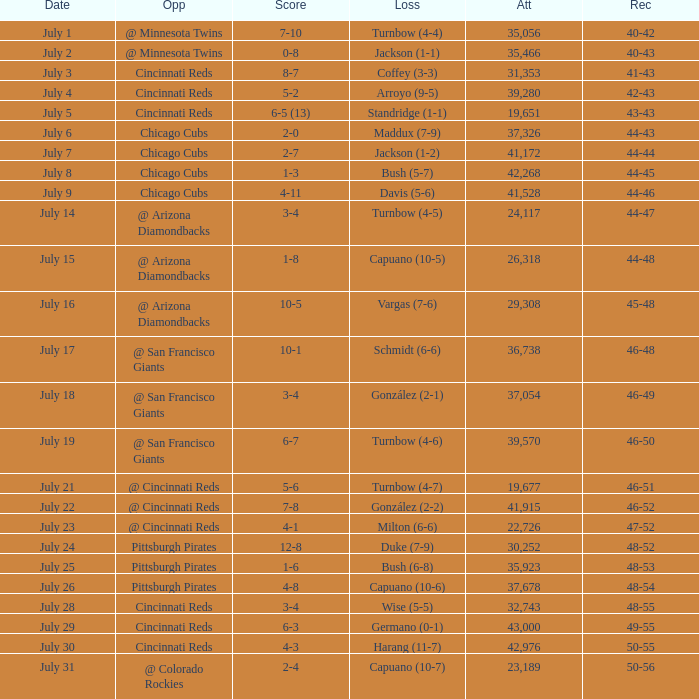What was the record at the game that had a score of 7-10? 40-42. 